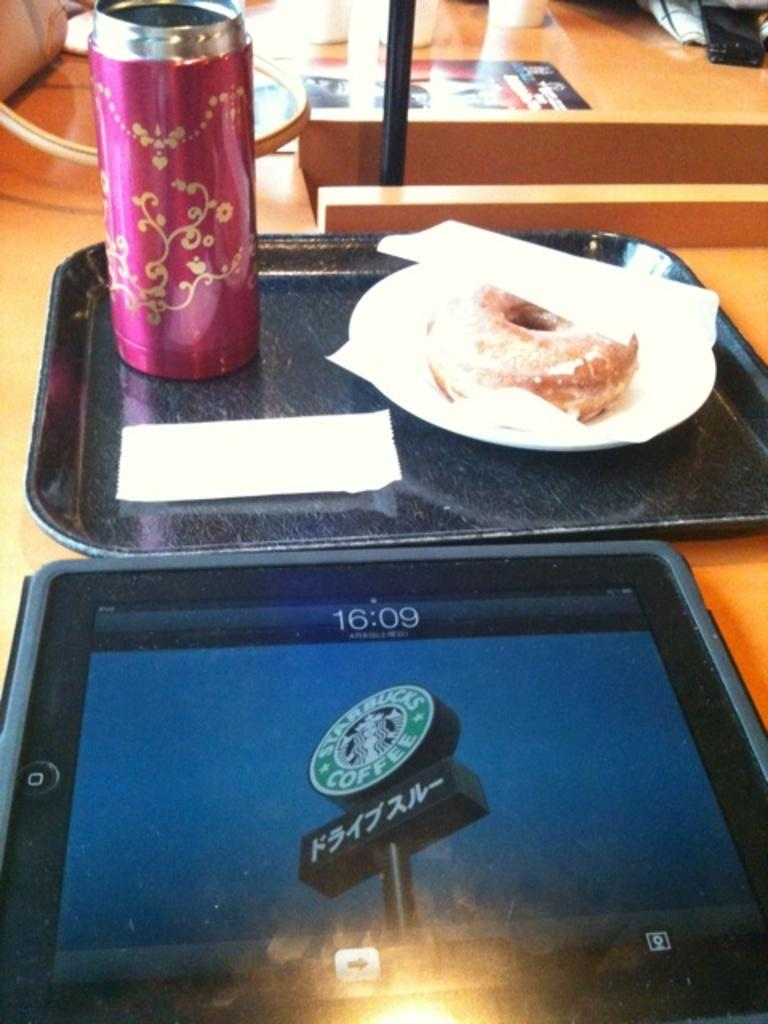What is the main object in the image? There is an object in the image, but the specific object is not mentioned. What type of container can be seen in the image? There is a bottle in the image. What type of writing material is present in the image? There is a paper in the image. What type of food is visible in the image? There is a doughnut in the image. Where are all these items located? All of these items are on a table. Reasoning: Let's think step by step in the image and identify the main subjects and objects based on the provided facts. We then formulate questions that focus on the location and characteristics of these subjects and objects, ensuring that each question can be answered definitively with the information given. We avoid yes/no questions and ensure that the language is simple and clear. Absurd Question/Answer: What type of suit is hanging on the wall in the image? There is no suit present in the image. What type of pickle is being used as a decoration in the image? There is no pickle present in the image. How is the payment being processed in the image? There is no mention of payment or any transaction in the image. 